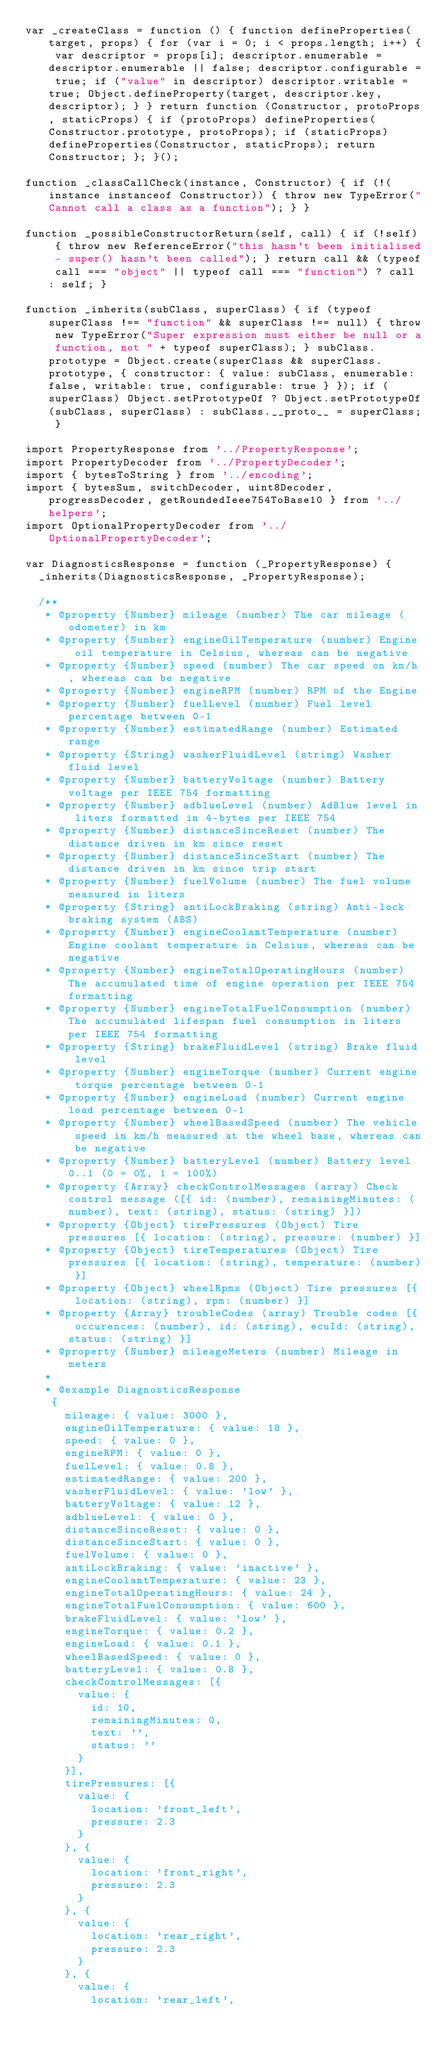Convert code to text. <code><loc_0><loc_0><loc_500><loc_500><_JavaScript_>var _createClass = function () { function defineProperties(target, props) { for (var i = 0; i < props.length; i++) { var descriptor = props[i]; descriptor.enumerable = descriptor.enumerable || false; descriptor.configurable = true; if ("value" in descriptor) descriptor.writable = true; Object.defineProperty(target, descriptor.key, descriptor); } } return function (Constructor, protoProps, staticProps) { if (protoProps) defineProperties(Constructor.prototype, protoProps); if (staticProps) defineProperties(Constructor, staticProps); return Constructor; }; }();

function _classCallCheck(instance, Constructor) { if (!(instance instanceof Constructor)) { throw new TypeError("Cannot call a class as a function"); } }

function _possibleConstructorReturn(self, call) { if (!self) { throw new ReferenceError("this hasn't been initialised - super() hasn't been called"); } return call && (typeof call === "object" || typeof call === "function") ? call : self; }

function _inherits(subClass, superClass) { if (typeof superClass !== "function" && superClass !== null) { throw new TypeError("Super expression must either be null or a function, not " + typeof superClass); } subClass.prototype = Object.create(superClass && superClass.prototype, { constructor: { value: subClass, enumerable: false, writable: true, configurable: true } }); if (superClass) Object.setPrototypeOf ? Object.setPrototypeOf(subClass, superClass) : subClass.__proto__ = superClass; }

import PropertyResponse from '../PropertyResponse';
import PropertyDecoder from '../PropertyDecoder';
import { bytesToString } from '../encoding';
import { bytesSum, switchDecoder, uint8Decoder, progressDecoder, getRoundedIeee754ToBase10 } from '../helpers';
import OptionalPropertyDecoder from '../OptionalPropertyDecoder';

var DiagnosticsResponse = function (_PropertyResponse) {
  _inherits(DiagnosticsResponse, _PropertyResponse);

  /**
   * @property {Number} mileage (number) The car mileage (odometer) in km
   * @property {Number} engineOilTemperature (number) Engine oil temperature in Celsius, whereas can be negative
   * @property {Number} speed (number) The car speed on km/h, whereas can be negative
   * @property {Number} engineRPM (number) RPM of the Engine
   * @property {Number} fuelLevel (number) Fuel level percentage between 0-1
   * @property {Number} estimatedRange (number) Estimated range
   * @property {String} washerFluidLevel (string) Washer fluid level
   * @property {Number} batteryVoltage (number) Battery voltage per IEEE 754 formatting
   * @property {Number} adblueLevel (number) AdBlue level in liters formatted in 4-bytes per IEEE 754
   * @property {Number} distanceSinceReset (number) The distance driven in km since reset
   * @property {Number} distanceSinceStart (number) The distance driven in km since trip start
   * @property {Number} fuelVolume (number) The fuel volume measured in liters
   * @property {String} antiLockBraking (string) Anti-lock braking system (ABS)
   * @property {Number} engineCoolantTemperature (number) Engine coolant temperature in Celsius, whereas can be negative
   * @property {Number} engineTotalOperatingHours (number) The accumulated time of engine operation per IEEE 754 formatting
   * @property {Number} engineTotalFuelConsumption (number) The accumulated lifespan fuel consumption in liters per IEEE 754 formatting
   * @property {String} brakeFluidLevel (string) Brake fluid level
   * @property {Number} engineTorque (number) Current engine torque percentage between 0-1
   * @property {Number} engineLoad (number) Current engine load percentage between 0-1
   * @property {Number} wheelBasedSpeed (number) The vehicle speed in km/h measured at the wheel base, whereas can be negative
   * @property {Number} batteryLevel (number) Battery level 0..1 (0 = 0%, 1 = 100%)
   * @property {Array} checkControlMessages (array) Check control message ([{ id: (number), remainingMinutes: (number), text: (string), status: (string) }])
   * @property {Object} tirePressures (Object) Tire pressures [{ location: (string), pressure: (number) }]
   * @property {Object} tireTemperatures (Object) Tire pressures [{ location: (string), temperature: (number) }]
   * @property {Object} wheelRpms (Object) Tire pressures [{ location: (string), rpm: (number) }]
   * @property {Array} troubleCodes (array) Trouble codes [{ occurences: (number), id: (string), ecuId: (string), status: (string) }]
   * @property {Number} mileageMeters (number) Mileage in meters
   *
   * @example DiagnosticsResponse
    {
      mileage: { value: 3000 },
      engineOilTemperature: { value: 18 },
      speed: { value: 0 },
      engineRPM: { value: 0 },
      fuelLevel: { value: 0.8 },
      estimatedRange: { value: 200 },
      washerFluidLevel: { value: 'low' },
      batteryVoltage: { value: 12 },
      adblueLevel: { value: 0 },
      distanceSinceReset: { value: 0 },
      distanceSinceStart: { value: 0 },
      fuelVolume: { value: 0 },
      antiLockBraking: { value: 'inactive' },
      engineCoolantTemperature: { value: 23 },
      engineTotalOperatingHours: { value: 24 },
      engineTotalFuelConsumption: { value: 600 },
      brakeFluidLevel: { value: 'low' },
      engineTorque: { value: 0.2 },
      engineLoad: { value: 0.1 },
      wheelBasedSpeed: { value: 0 },
      batteryLevel: { value: 0.8 },
      checkControlMessages: [{
        value: {
          id: 10,
          remainingMinutes: 0,
          text: '',
          status: ''
        }
      }],
      tirePressures: [{
        value: {
          location: 'front_left',
          pressure: 2.3
        }
      }, {
        value: {
          location: 'front_right',
          pressure: 2.3
        }
      }, {
        value: {
          location: 'rear_right',
          pressure: 2.3
        }
      }, {
        value: {
          location: 'rear_left',</code> 